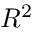<formula> <loc_0><loc_0><loc_500><loc_500>R ^ { 2 }</formula> 